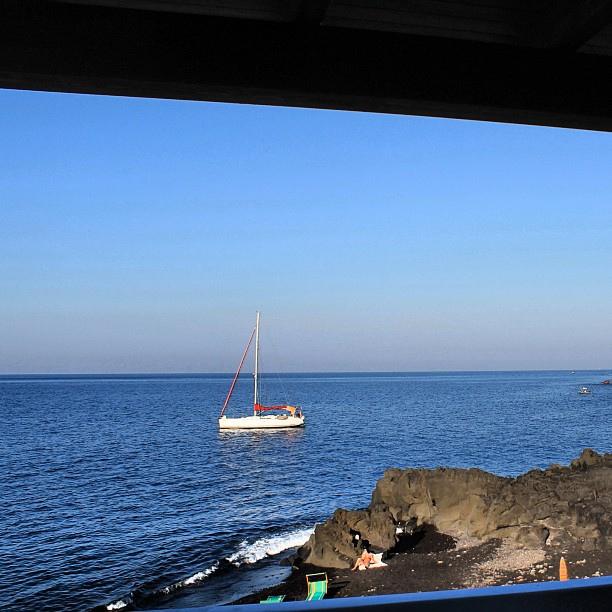How many boats can be seen?
Concise answer only. 1. Where is the boat?
Keep it brief. In water. What shape would the sail be in if it was unfurled on this boat?
Be succinct. Triangle. 